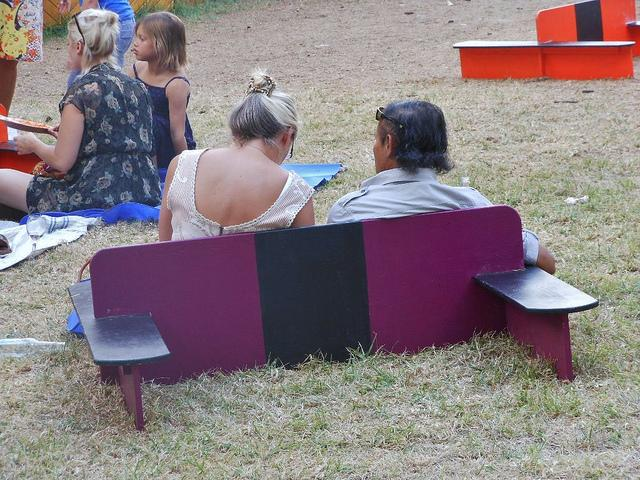Why are they so close together? talking 